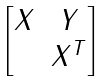Convert formula to latex. <formula><loc_0><loc_0><loc_500><loc_500>\begin{bmatrix} X & Y \\ & X ^ { T } \end{bmatrix}</formula> 